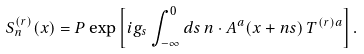Convert formula to latex. <formula><loc_0><loc_0><loc_500><loc_500>S ^ { ( r ) } _ { n } ( x ) = P \exp \left [ i g _ { s } \int _ { - \infty } ^ { 0 } d s \, n \cdot A ^ { a } ( x + n s ) \, { T } ^ { ( r ) a } \right ] .</formula> 